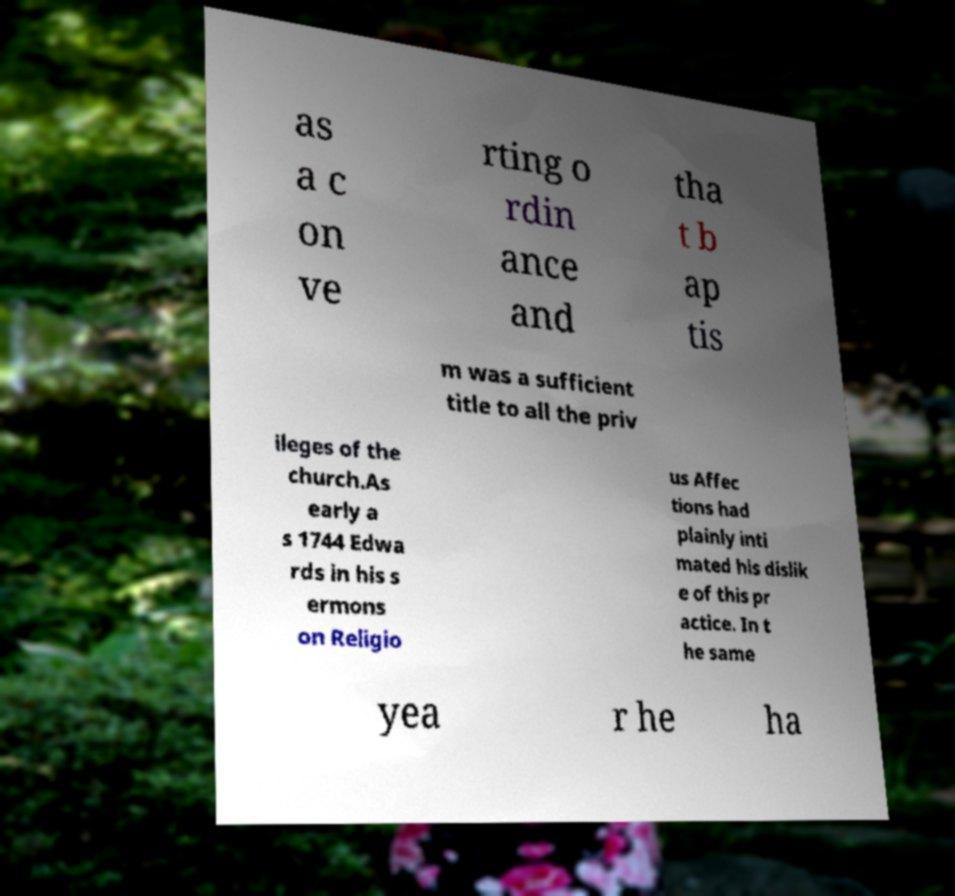I need the written content from this picture converted into text. Can you do that? as a c on ve rting o rdin ance and tha t b ap tis m was a sufficient title to all the priv ileges of the church.As early a s 1744 Edwa rds in his s ermons on Religio us Affec tions had plainly inti mated his dislik e of this pr actice. In t he same yea r he ha 